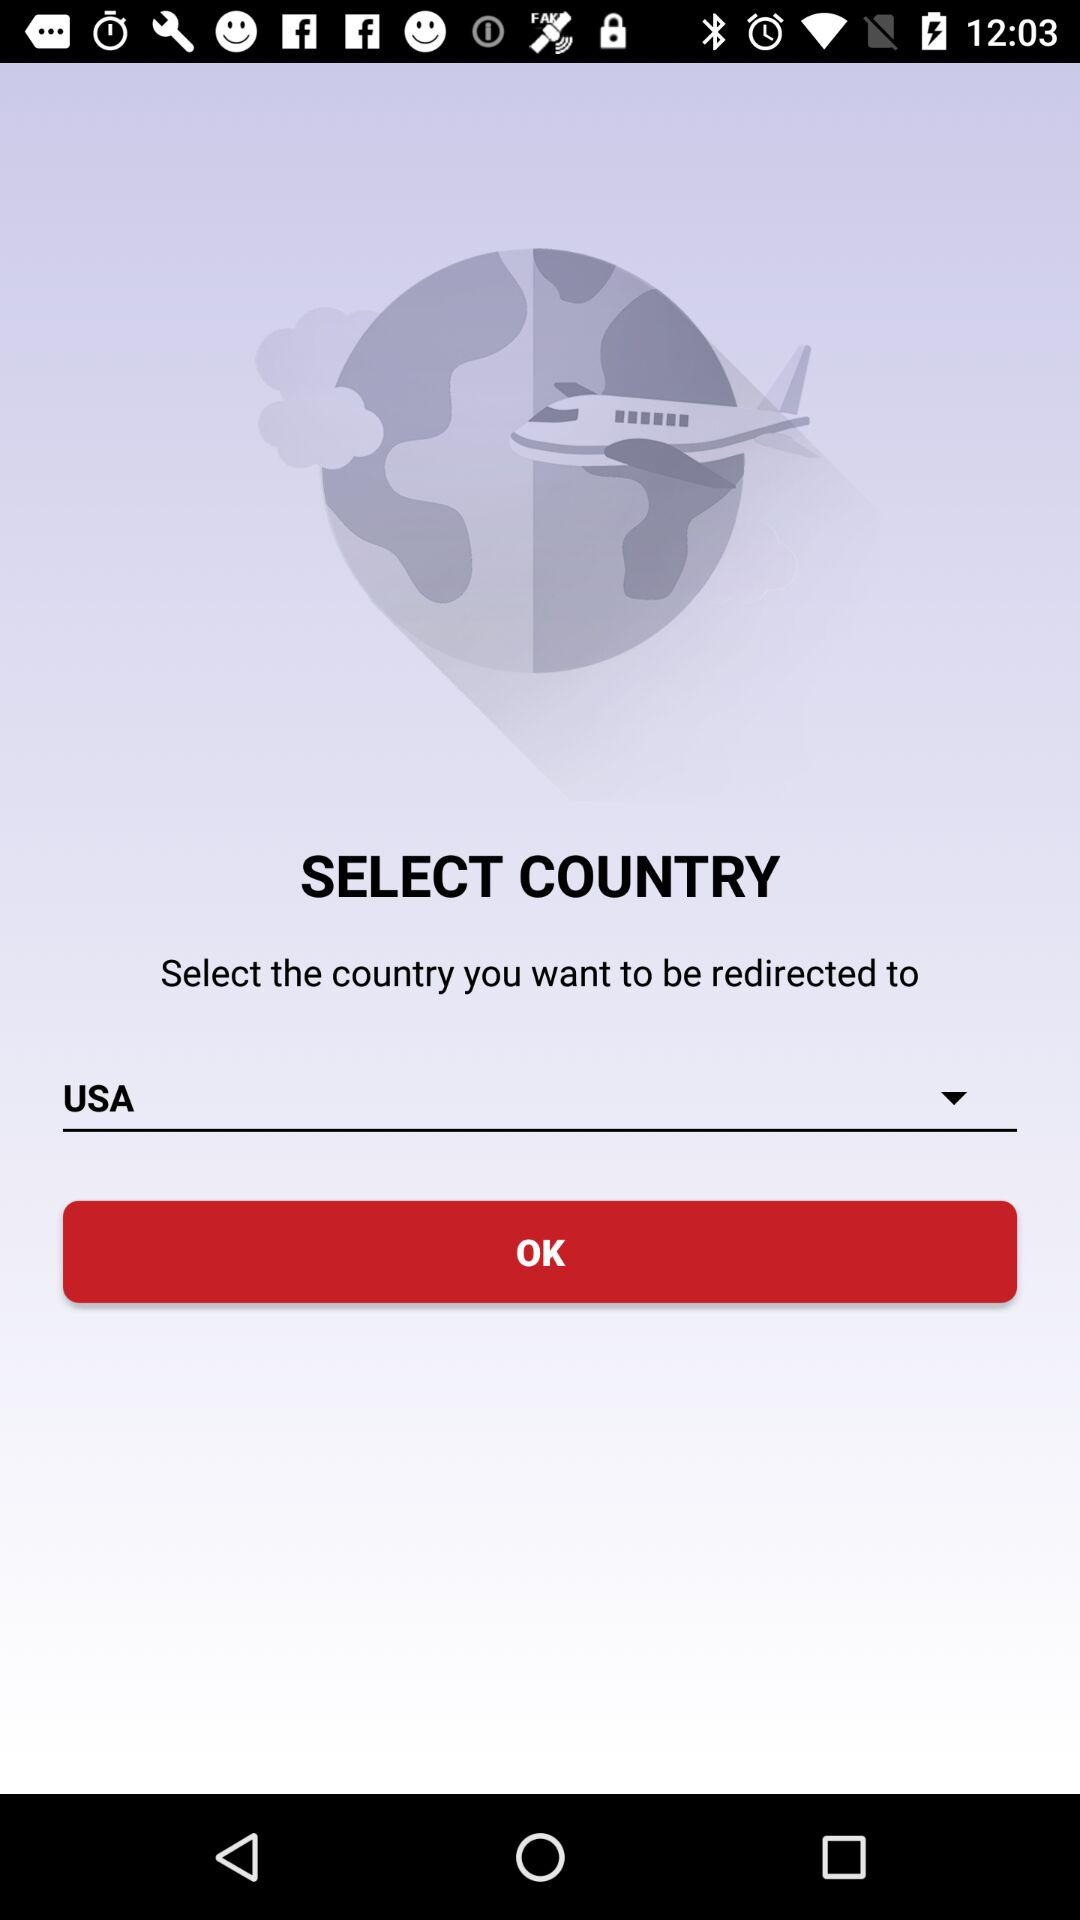What is the name of the country? The name of the country is the USA. 